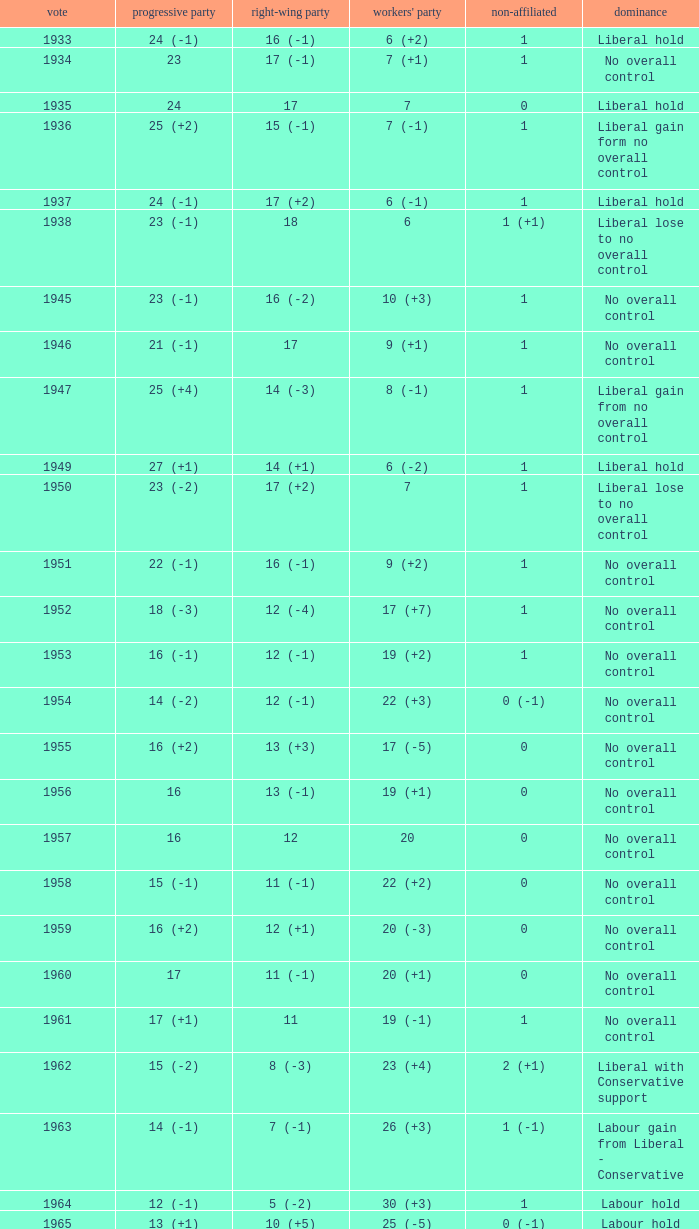What is the number of Independents elected in the year Labour won 26 (+3) seats? 1 (-1). 